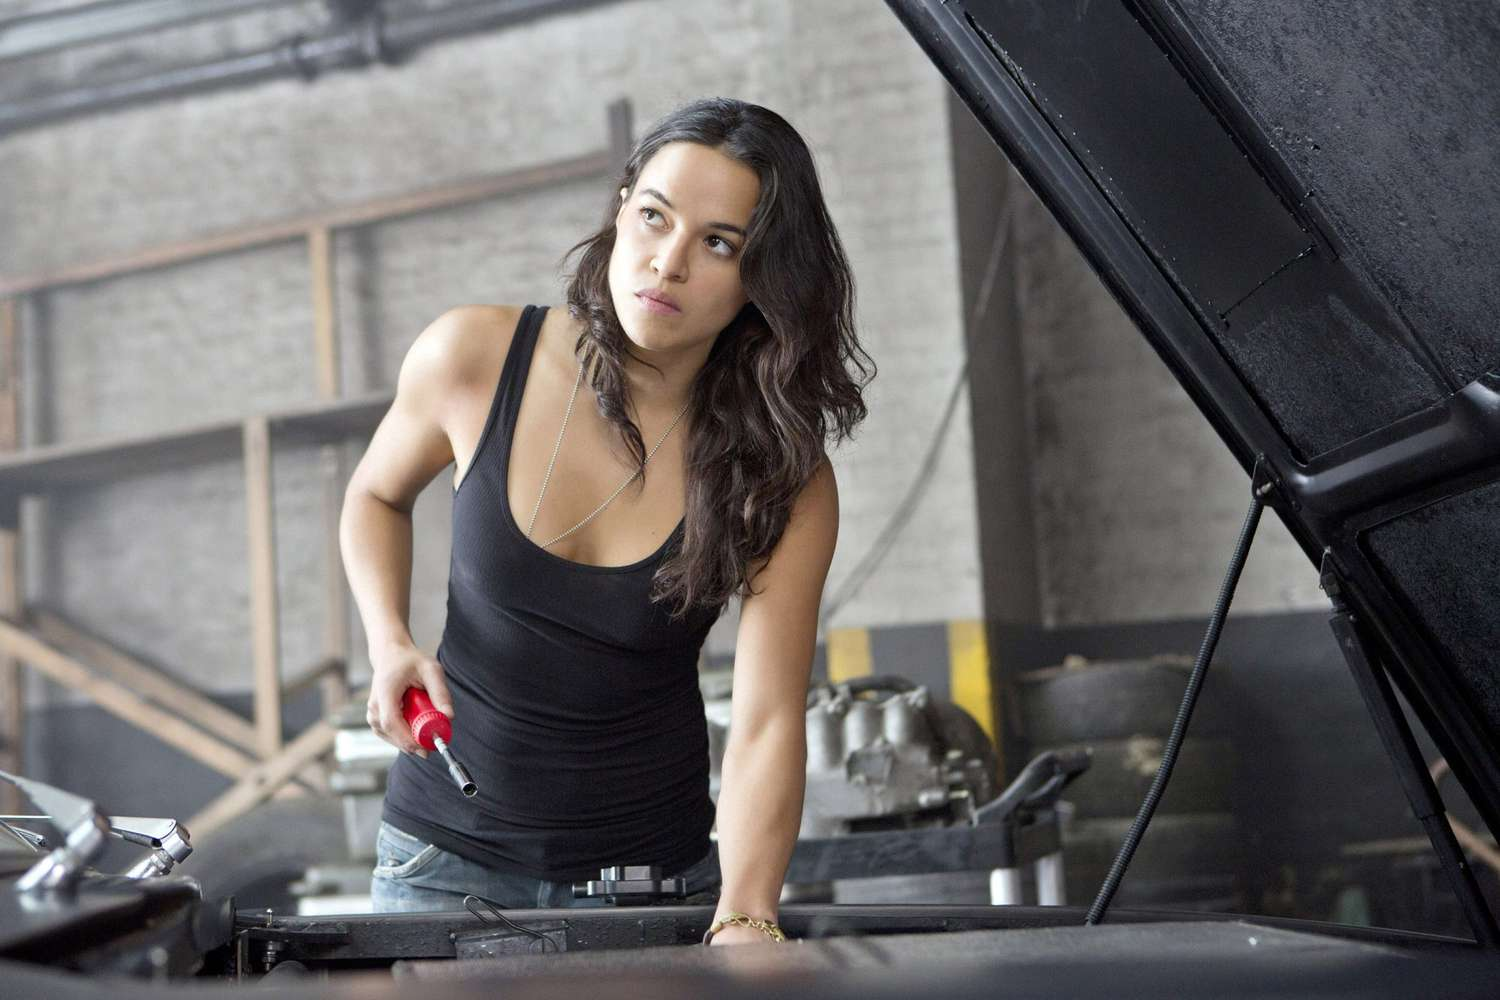What do you think she is working on in the car? Based on her focused demeanor and the large red wrench in her hand, it appears she might be working on something substantial within the car's engine bay. Possible tasks include tightening or loosening larger components, such as bolts connected to the engine block, replacing spark plugs, or addressing issues with the car's cooling system. Given the typical use of such a wrench, her work is likely essential for the car's basic operation and performance. 